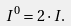<formula> <loc_0><loc_0><loc_500><loc_500>I ^ { 0 } = 2 \cdot I .</formula> 